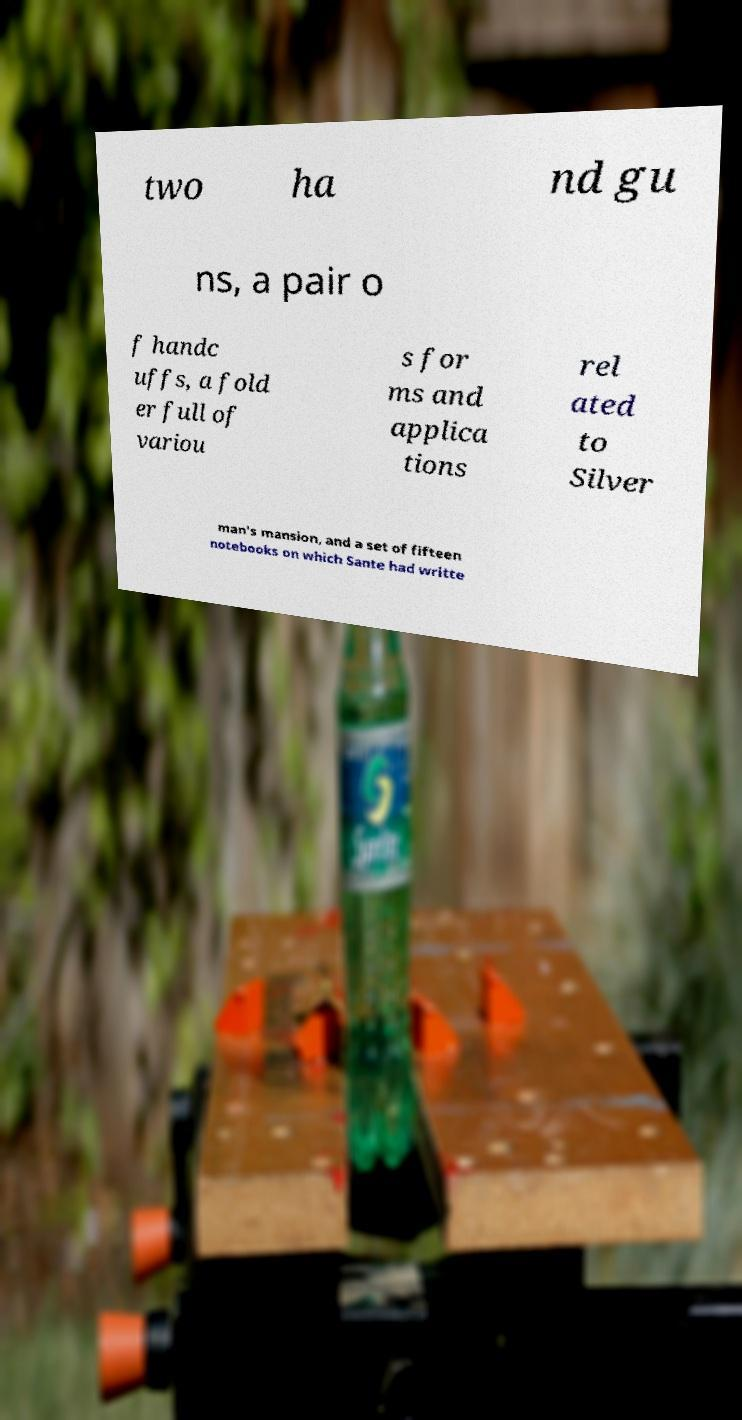What messages or text are displayed in this image? I need them in a readable, typed format. two ha nd gu ns, a pair o f handc uffs, a fold er full of variou s for ms and applica tions rel ated to Silver man's mansion, and a set of fifteen notebooks on which Sante had writte 